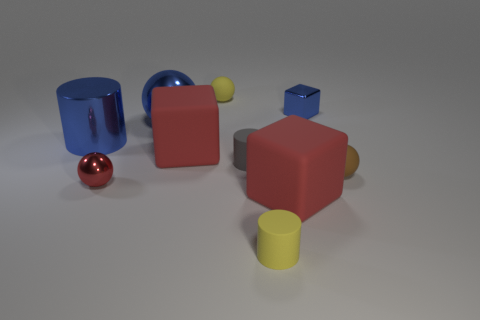Subtract all purple blocks. Subtract all yellow balls. How many blocks are left? 3 Subtract all cylinders. How many objects are left? 7 Add 2 tiny gray cylinders. How many tiny gray cylinders are left? 3 Add 3 large metallic spheres. How many large metallic spheres exist? 4 Subtract 0 cyan cubes. How many objects are left? 10 Subtract all yellow cylinders. Subtract all yellow matte balls. How many objects are left? 8 